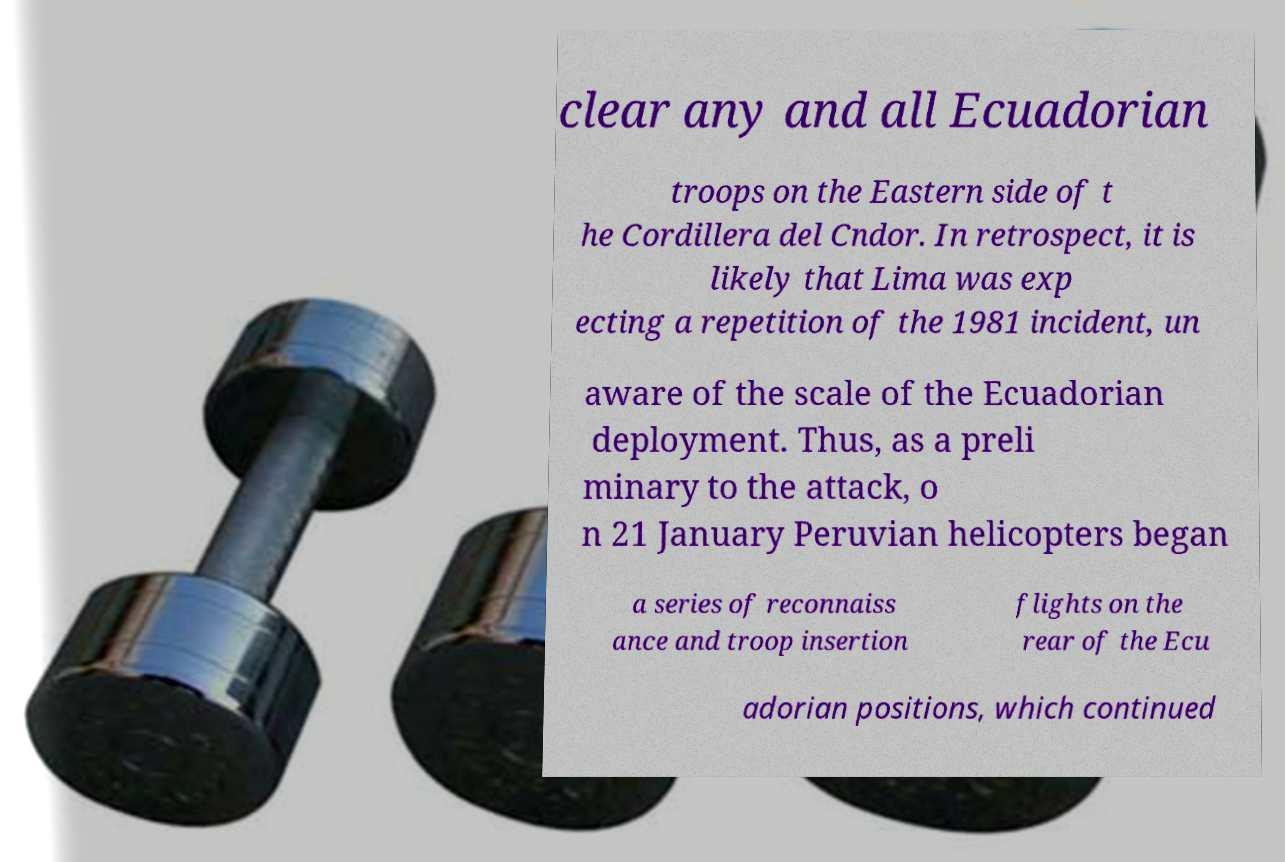What messages or text are displayed in this image? I need them in a readable, typed format. clear any and all Ecuadorian troops on the Eastern side of t he Cordillera del Cndor. In retrospect, it is likely that Lima was exp ecting a repetition of the 1981 incident, un aware of the scale of the Ecuadorian deployment. Thus, as a preli minary to the attack, o n 21 January Peruvian helicopters began a series of reconnaiss ance and troop insertion flights on the rear of the Ecu adorian positions, which continued 